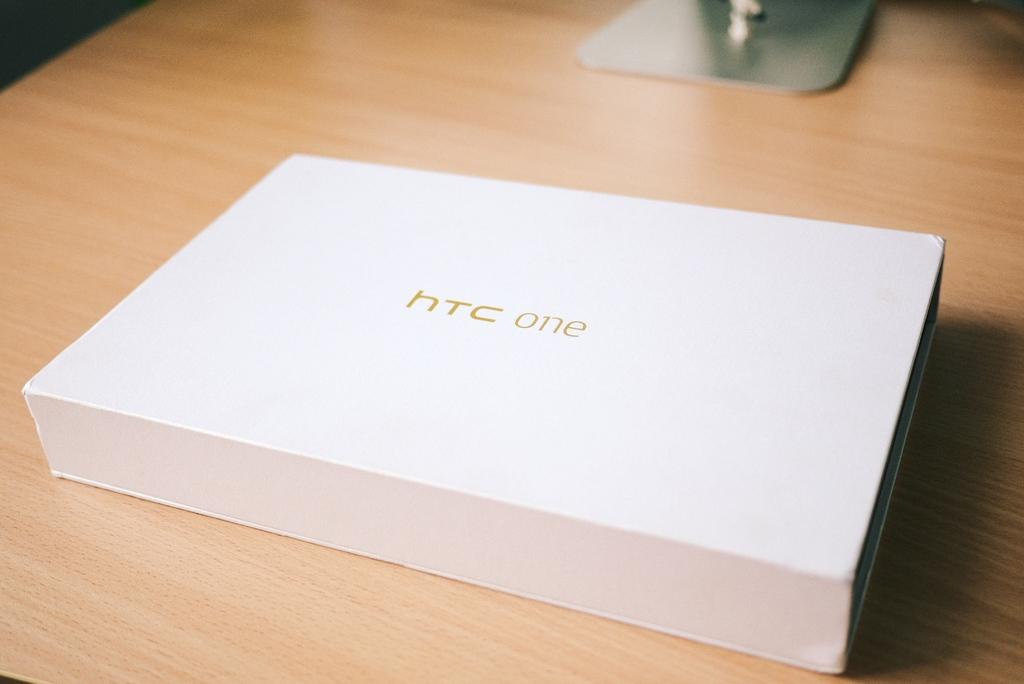What is the main color of the object in the image? The main color of the object in the image is white. What is written on the white object? There is writing on the white object. How would you describe the quality of the image in the background? The image is blurry in the background. How many cats are sitting on the head of the white object in the image? There are no cats present in the image, and the white object does not have a head. 